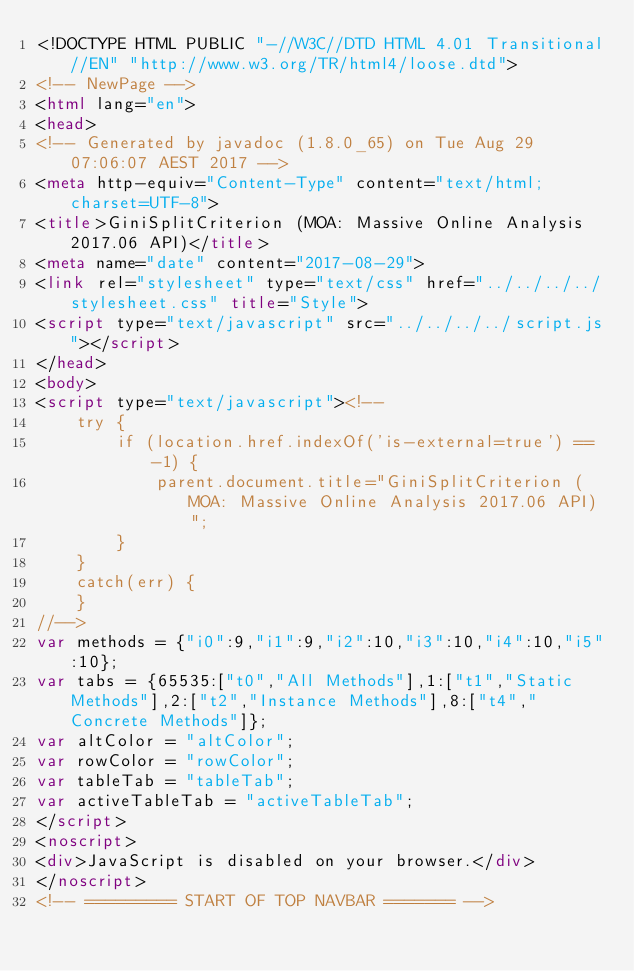<code> <loc_0><loc_0><loc_500><loc_500><_HTML_><!DOCTYPE HTML PUBLIC "-//W3C//DTD HTML 4.01 Transitional//EN" "http://www.w3.org/TR/html4/loose.dtd">
<!-- NewPage -->
<html lang="en">
<head>
<!-- Generated by javadoc (1.8.0_65) on Tue Aug 29 07:06:07 AEST 2017 -->
<meta http-equiv="Content-Type" content="text/html; charset=UTF-8">
<title>GiniSplitCriterion (MOA: Massive Online Analysis 2017.06 API)</title>
<meta name="date" content="2017-08-29">
<link rel="stylesheet" type="text/css" href="../../../../stylesheet.css" title="Style">
<script type="text/javascript" src="../../../../script.js"></script>
</head>
<body>
<script type="text/javascript"><!--
    try {
        if (location.href.indexOf('is-external=true') == -1) {
            parent.document.title="GiniSplitCriterion (MOA: Massive Online Analysis 2017.06 API)";
        }
    }
    catch(err) {
    }
//-->
var methods = {"i0":9,"i1":9,"i2":10,"i3":10,"i4":10,"i5":10};
var tabs = {65535:["t0","All Methods"],1:["t1","Static Methods"],2:["t2","Instance Methods"],8:["t4","Concrete Methods"]};
var altColor = "altColor";
var rowColor = "rowColor";
var tableTab = "tableTab";
var activeTableTab = "activeTableTab";
</script>
<noscript>
<div>JavaScript is disabled on your browser.</div>
</noscript>
<!-- ========= START OF TOP NAVBAR ======= --></code> 